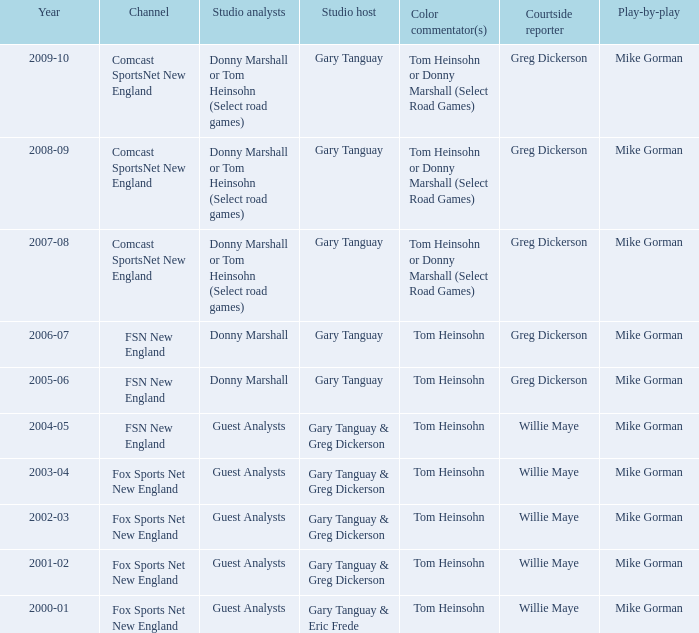Which Courtside reporter has a Channel of fsn new england in 2006-07? Greg Dickerson. 